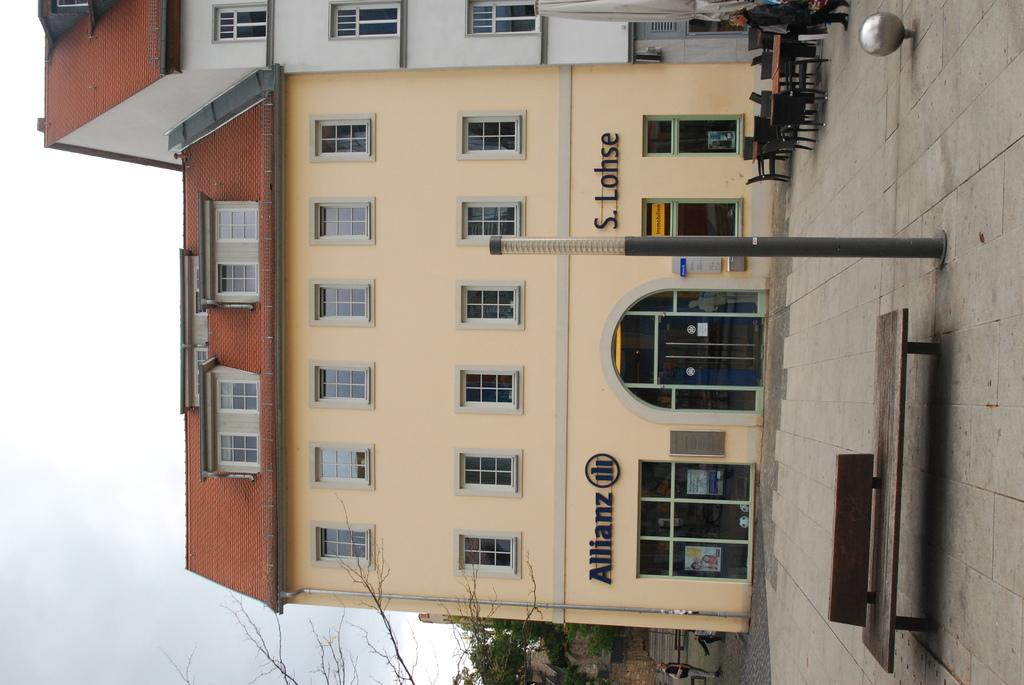What type of surface can be seen in the image? There is ground visible in the image. What type of furniture is present in the image? There is a bench, chairs, and a table in the image. What other objects can be seen in the image? There is a pole in the image. Are there any people in the image? Yes, there is a person standing in the image. What type of natural elements are present in the image? There are trees in the image. What type of man-made structures are present in the image? There are buildings in the image. What can be seen in the background of the image? The sky is visible in the background of the image. What type of account does the person standing in the image have? There is no information about the person's account in the image. What type of notebook is the monkey holding in the image? There is no monkey present in the image. 